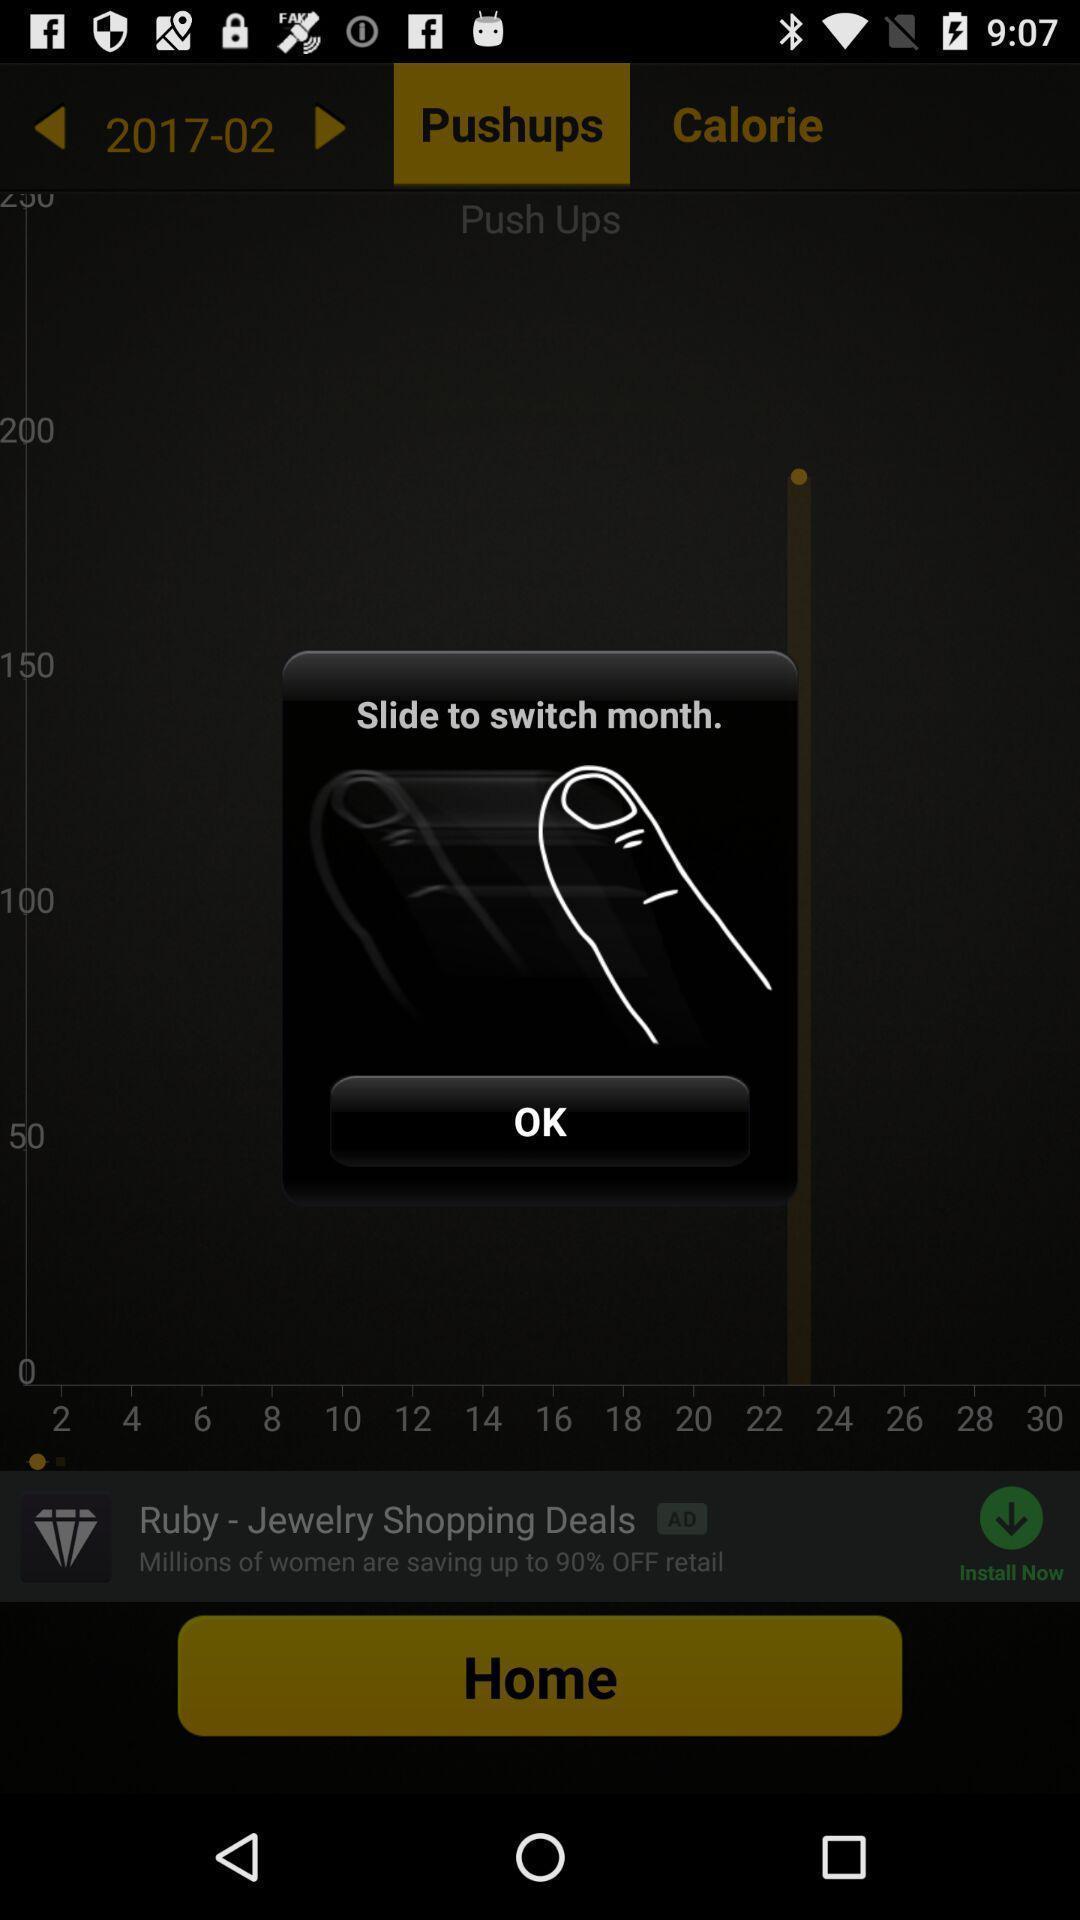Explain what's happening in this screen capture. Slide gesture in a workouts app. 